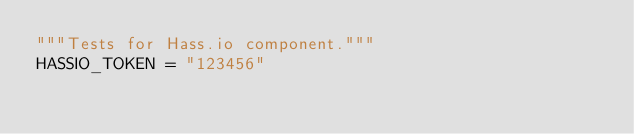<code> <loc_0><loc_0><loc_500><loc_500><_Python_>"""Tests for Hass.io component."""
HASSIO_TOKEN = "123456"
</code> 